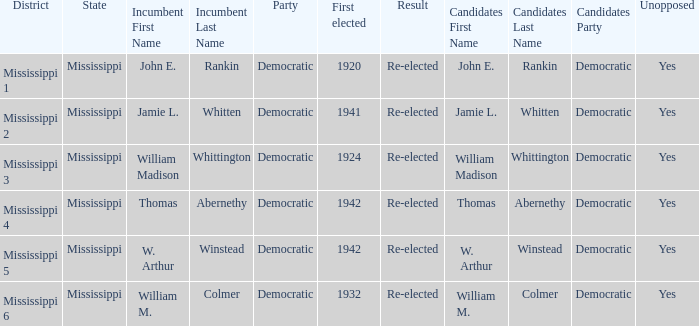What is the incumbent from 1941? Jamie L. Whitten. 